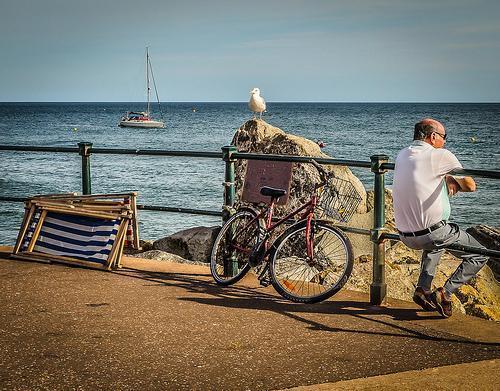How many boats are in the water?
Give a very brief answer. 1. 